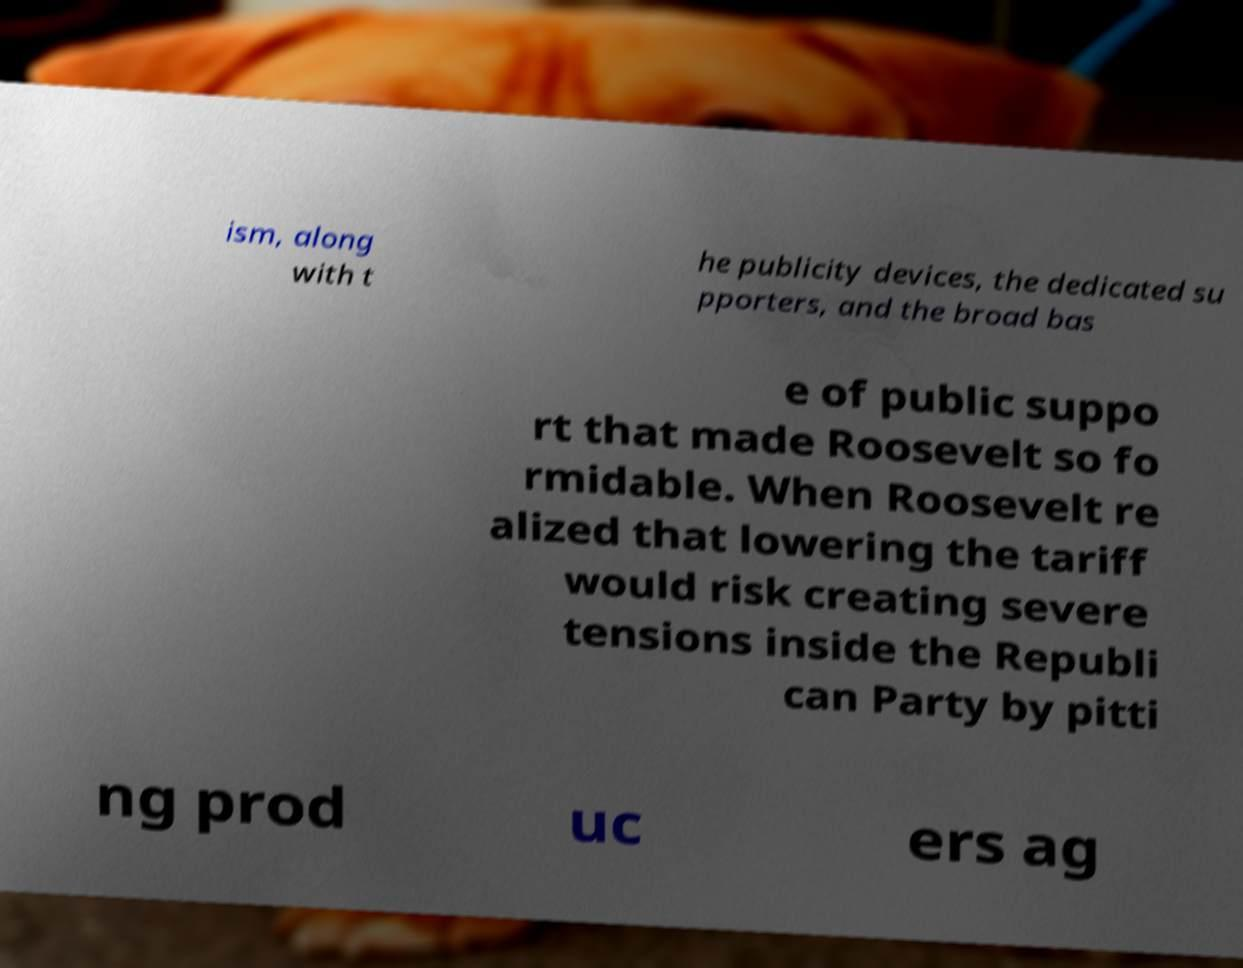Can you read and provide the text displayed in the image?This photo seems to have some interesting text. Can you extract and type it out for me? ism, along with t he publicity devices, the dedicated su pporters, and the broad bas e of public suppo rt that made Roosevelt so fo rmidable. When Roosevelt re alized that lowering the tariff would risk creating severe tensions inside the Republi can Party by pitti ng prod uc ers ag 